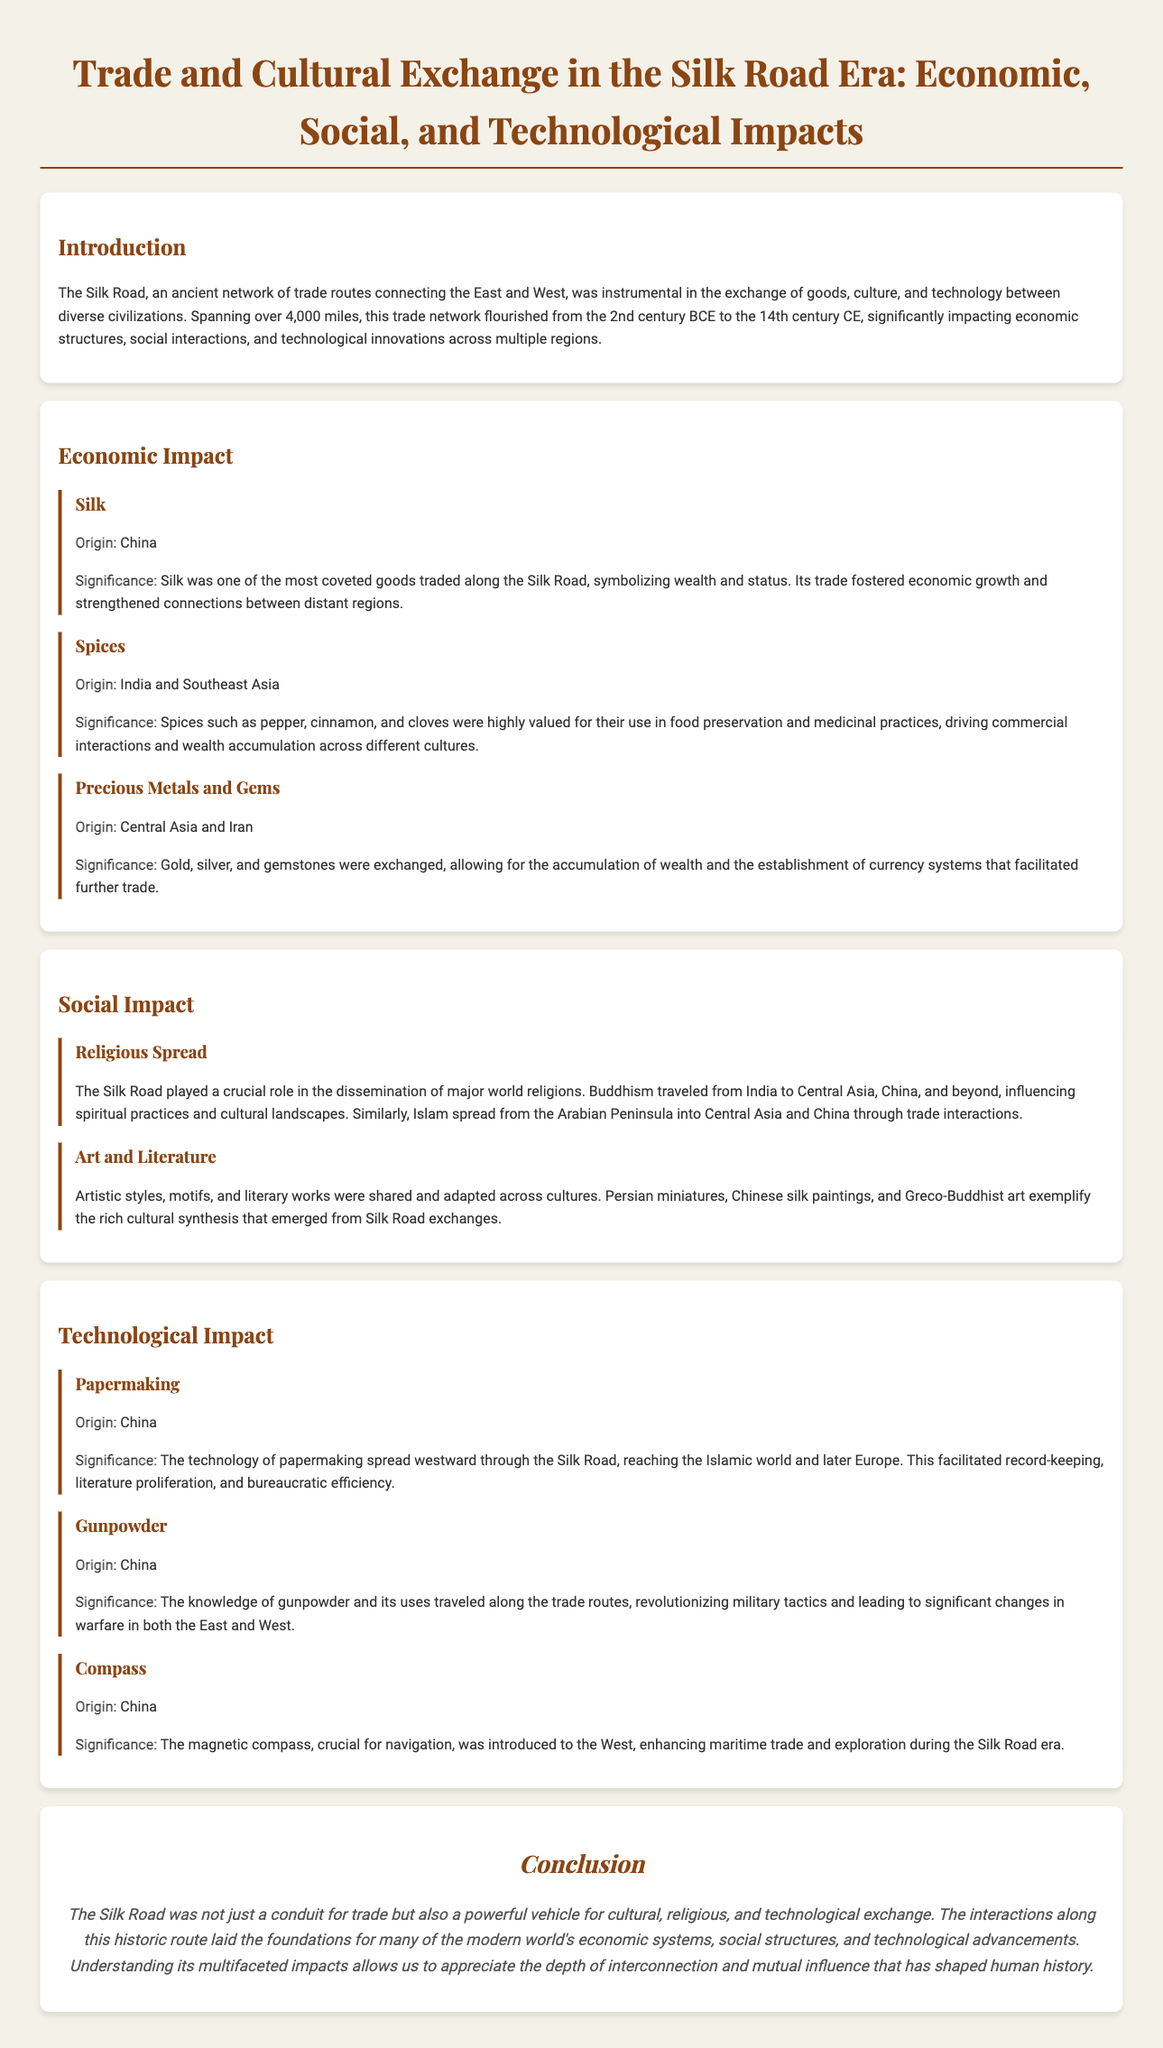what were the main goods traded along the Silk Road? The document lists silk, spices, and precious metals and gems as the main goods traded along the Silk Road.
Answer: silk, spices, precious metals and gems which religion spread from India through the Silk Road? The document mentions that Buddhism traveled from India to Central Asia, China, and beyond, influencing cultural landscapes.
Answer: Buddhism what was one significant technological advancement introduced to the West from the East? The document states that the magnetic compass was introduced to the West, enhancing maritime trade.
Answer: magnetic compass which product was used for food preservation and medicinal practices? The document implies that spices such as pepper, cinnamon, and cloves were highly valued for these purposes.
Answer: spices what was the significance of silk in the trade? The document describes silk as a coveted good symbolizing wealth and status, fostering economic growth.
Answer: wealth and status what role did the Silk Road play in military tactics? The document notes that the knowledge of gunpowder revolutionized military tactics along the trade routes.
Answer: revolutionized military tactics how did papermaking technology spread? According to the document, the technology of papermaking spread westward through the Silk Road to the Islamic world and Europe.
Answer: westward what is one example of cultural exchange mentioned in the document? The document showcases the sharing and adaptation of artistic styles and literary works across cultures, such as Persian miniatures and Chinese silk paintings.
Answer: Persian miniatures when did the Silk Road flourish? The document states that the Silk Road flourished from the 2nd century BCE to the 14th century CE.
Answer: 2nd century BCE to 14th century CE 